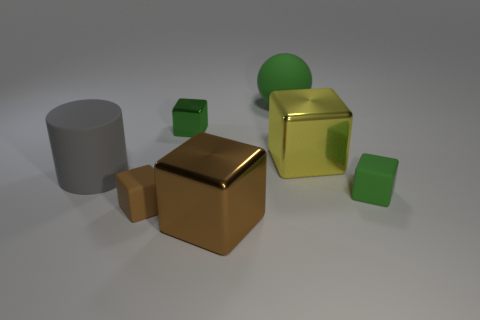Subtract all yellow blocks. How many blocks are left? 4 Subtract all brown shiny blocks. How many blocks are left? 4 Add 3 big gray matte cylinders. How many objects exist? 10 Subtract all yellow cylinders. Subtract all green cubes. How many cylinders are left? 1 Subtract all cylinders. How many objects are left? 6 Add 6 matte cylinders. How many matte cylinders exist? 7 Subtract 0 purple spheres. How many objects are left? 7 Subtract all brown shiny things. Subtract all large green balls. How many objects are left? 5 Add 4 brown shiny blocks. How many brown shiny blocks are left? 5 